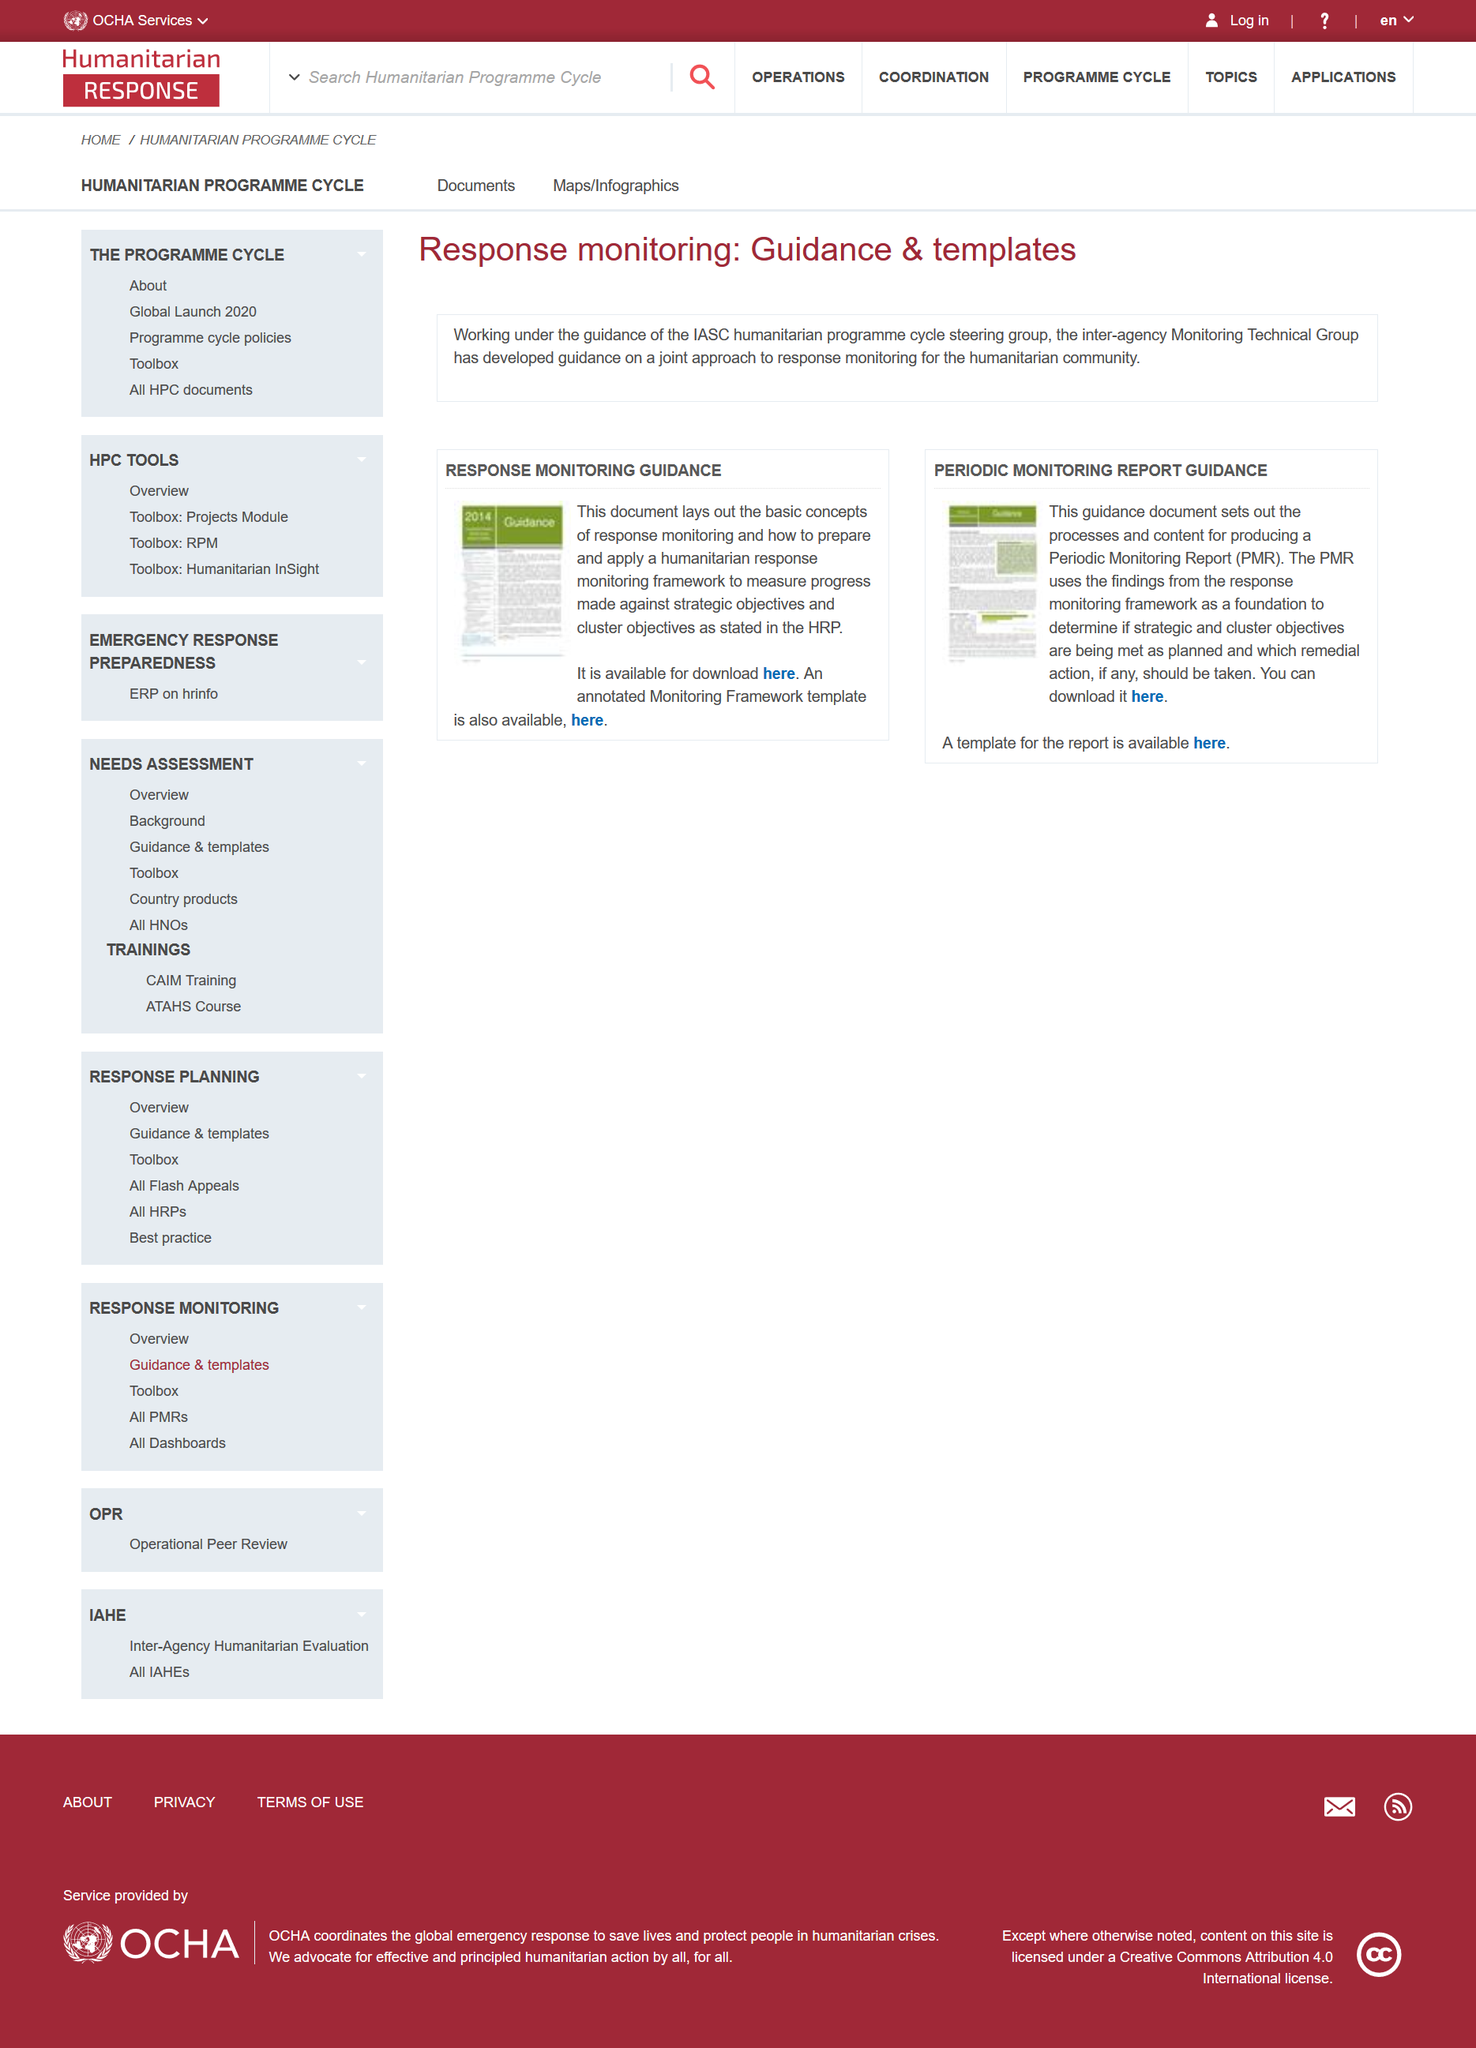Outline some significant characteristics in this image. The Monitory Guidance document is available for download, as it is. Periodic Monitoring Reports are commonly referred to as PMRs. 